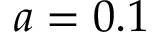<formula> <loc_0><loc_0><loc_500><loc_500>a = 0 . 1</formula> 